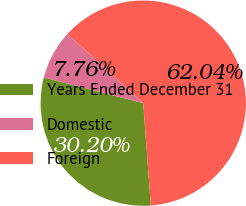Convert chart. <chart><loc_0><loc_0><loc_500><loc_500><pie_chart><fcel>Years Ended December 31<fcel>Domestic<fcel>Foreign<nl><fcel>30.2%<fcel>7.76%<fcel>62.04%<nl></chart> 